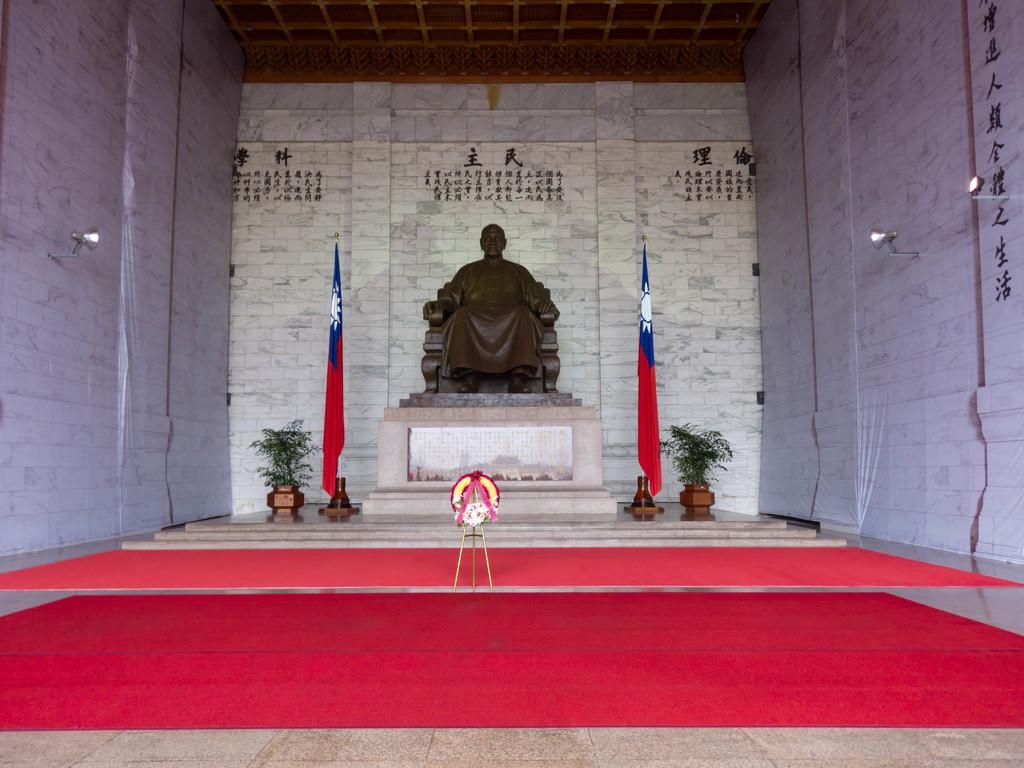Please provide a concise description of this image. In this image we can see a statue in the middle of the image and there are two flags and potted plants. We can see two red carpets on the floor and there are few lights attached to the wall and in the background, we can see some text on the wall. 